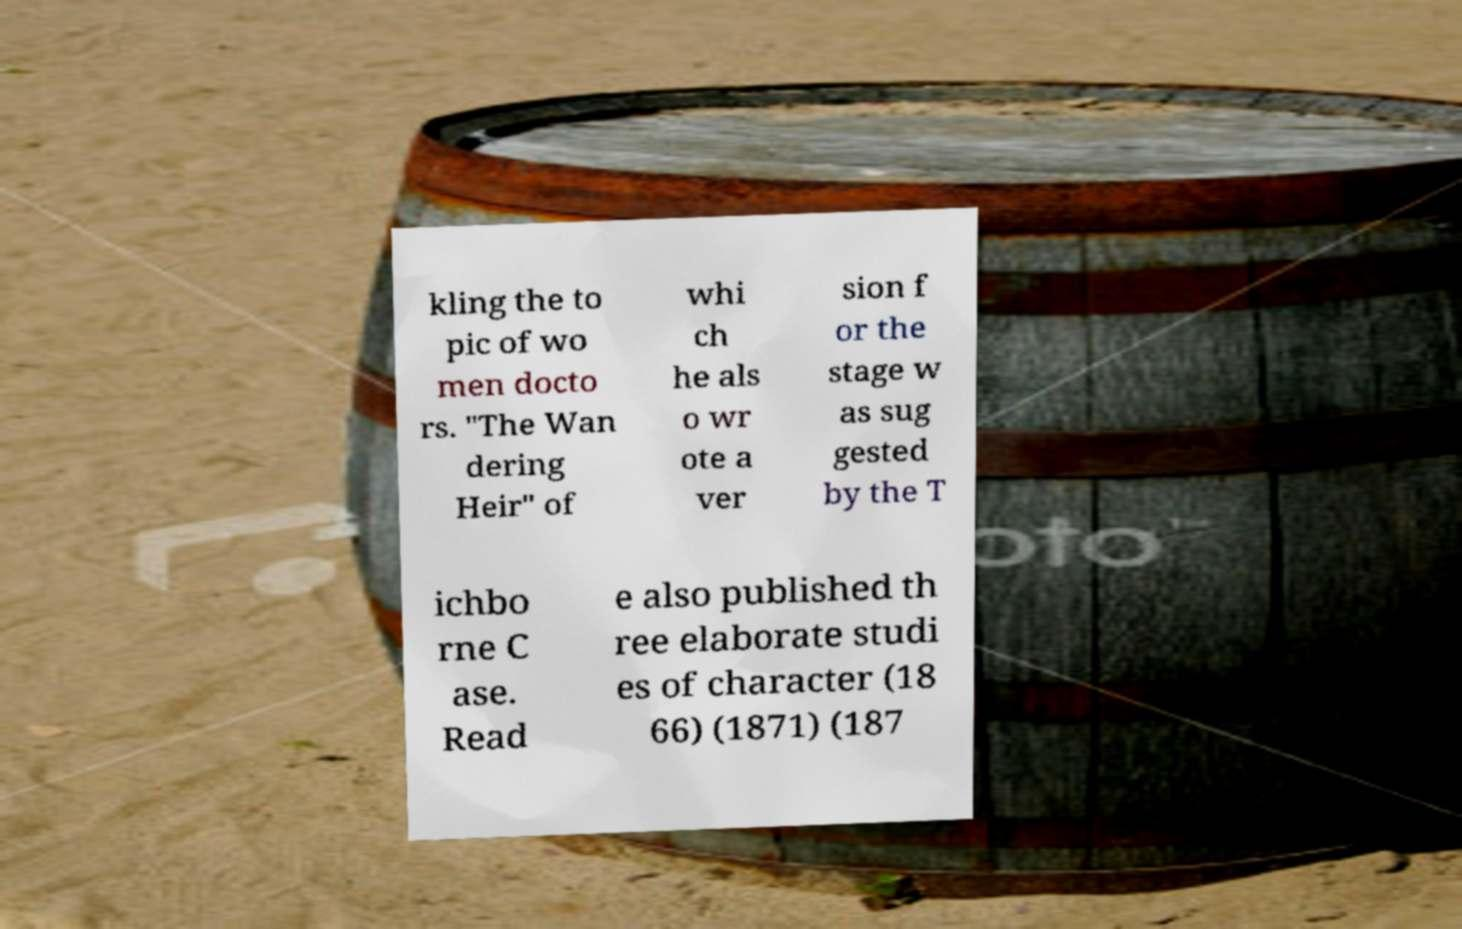Please identify and transcribe the text found in this image. kling the to pic of wo men docto rs. "The Wan dering Heir" of whi ch he als o wr ote a ver sion f or the stage w as sug gested by the T ichbo rne C ase. Read e also published th ree elaborate studi es of character (18 66) (1871) (187 